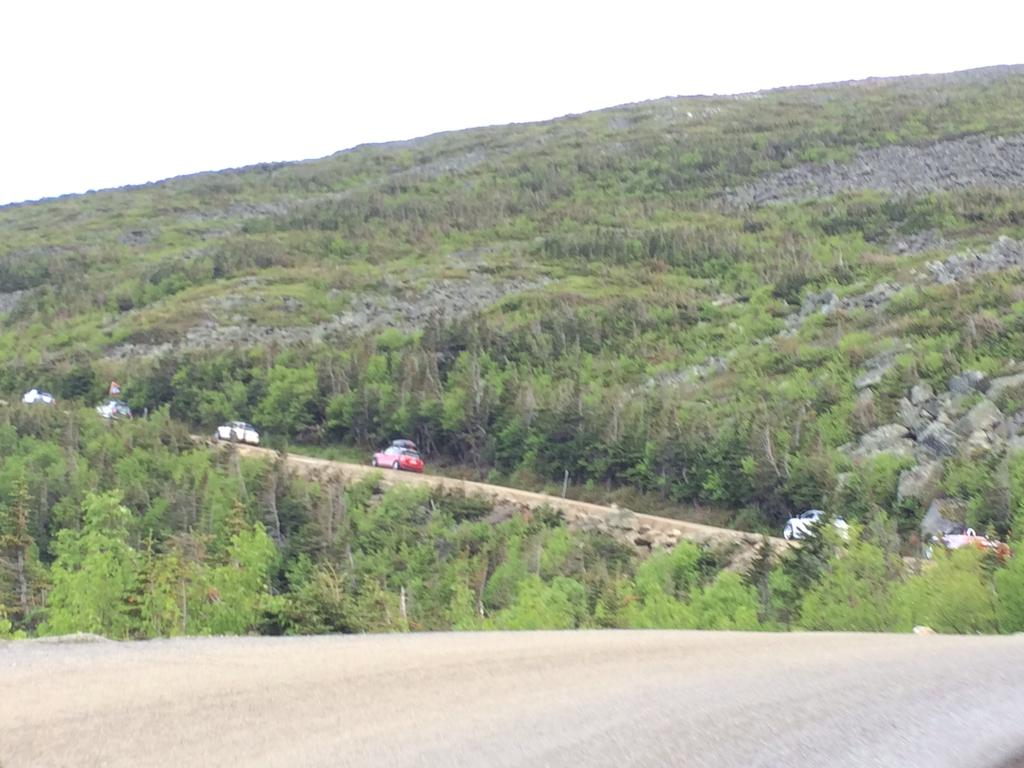What is in the foreground of the image? There is a road in the foreground of the image. What is happening on the road in the background? Vehicles are moving on the road in the background. What type of natural elements can be seen in the background of the image? There are trees and a cliff in the background of the image. What is visible at the top of the image? The sky is visible at the top of the image. What type of cloth is draped over the structure in the image? There is no structure or cloth present in the image. 